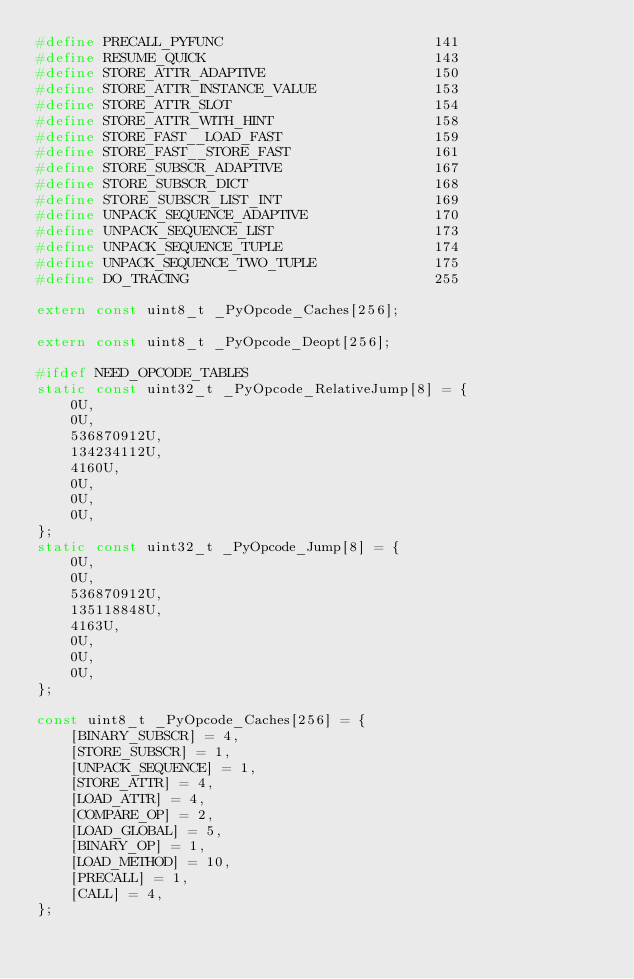Convert code to text. <code><loc_0><loc_0><loc_500><loc_500><_C_>#define PRECALL_PYFUNC                         141
#define RESUME_QUICK                           143
#define STORE_ATTR_ADAPTIVE                    150
#define STORE_ATTR_INSTANCE_VALUE              153
#define STORE_ATTR_SLOT                        154
#define STORE_ATTR_WITH_HINT                   158
#define STORE_FAST__LOAD_FAST                  159
#define STORE_FAST__STORE_FAST                 161
#define STORE_SUBSCR_ADAPTIVE                  167
#define STORE_SUBSCR_DICT                      168
#define STORE_SUBSCR_LIST_INT                  169
#define UNPACK_SEQUENCE_ADAPTIVE               170
#define UNPACK_SEQUENCE_LIST                   173
#define UNPACK_SEQUENCE_TUPLE                  174
#define UNPACK_SEQUENCE_TWO_TUPLE              175
#define DO_TRACING                             255

extern const uint8_t _PyOpcode_Caches[256];

extern const uint8_t _PyOpcode_Deopt[256];

#ifdef NEED_OPCODE_TABLES
static const uint32_t _PyOpcode_RelativeJump[8] = {
    0U,
    0U,
    536870912U,
    134234112U,
    4160U,
    0U,
    0U,
    0U,
};
static const uint32_t _PyOpcode_Jump[8] = {
    0U,
    0U,
    536870912U,
    135118848U,
    4163U,
    0U,
    0U,
    0U,
};

const uint8_t _PyOpcode_Caches[256] = {
    [BINARY_SUBSCR] = 4,
    [STORE_SUBSCR] = 1,
    [UNPACK_SEQUENCE] = 1,
    [STORE_ATTR] = 4,
    [LOAD_ATTR] = 4,
    [COMPARE_OP] = 2,
    [LOAD_GLOBAL] = 5,
    [BINARY_OP] = 1,
    [LOAD_METHOD] = 10,
    [PRECALL] = 1,
    [CALL] = 4,
};
</code> 